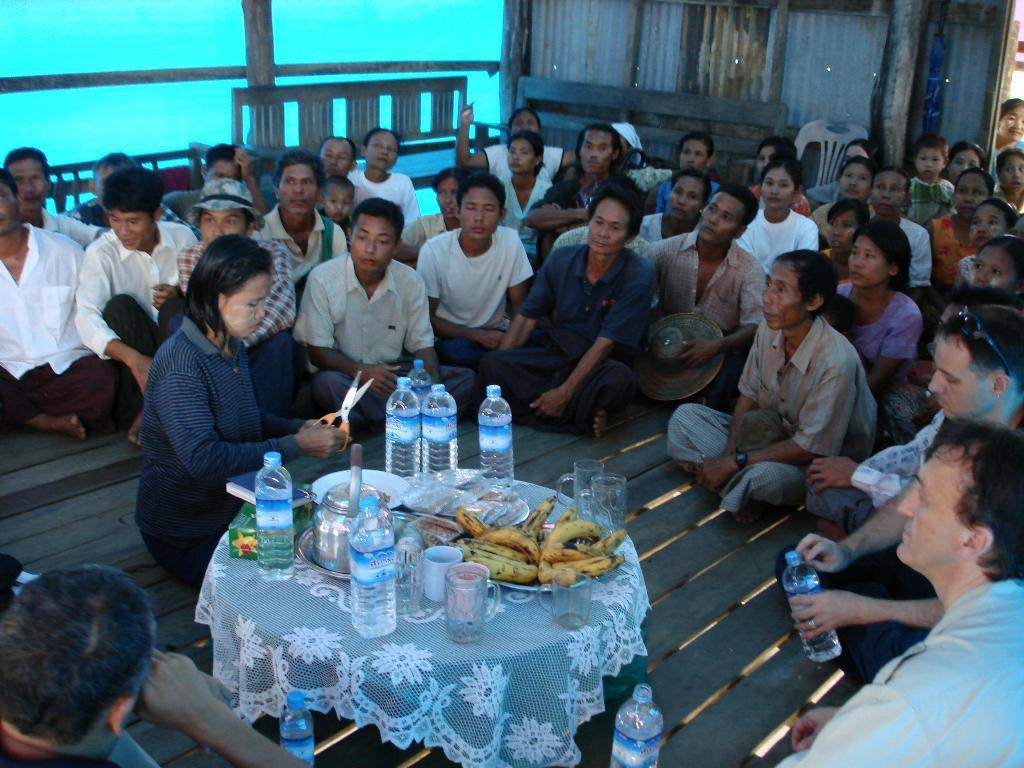In one or two sentences, can you explain what this image depicts? In the image there are man people sat on floor around a table which had water bottle,banana and bowl on it, in front of table there is a woman sat with scissor in her hand. 